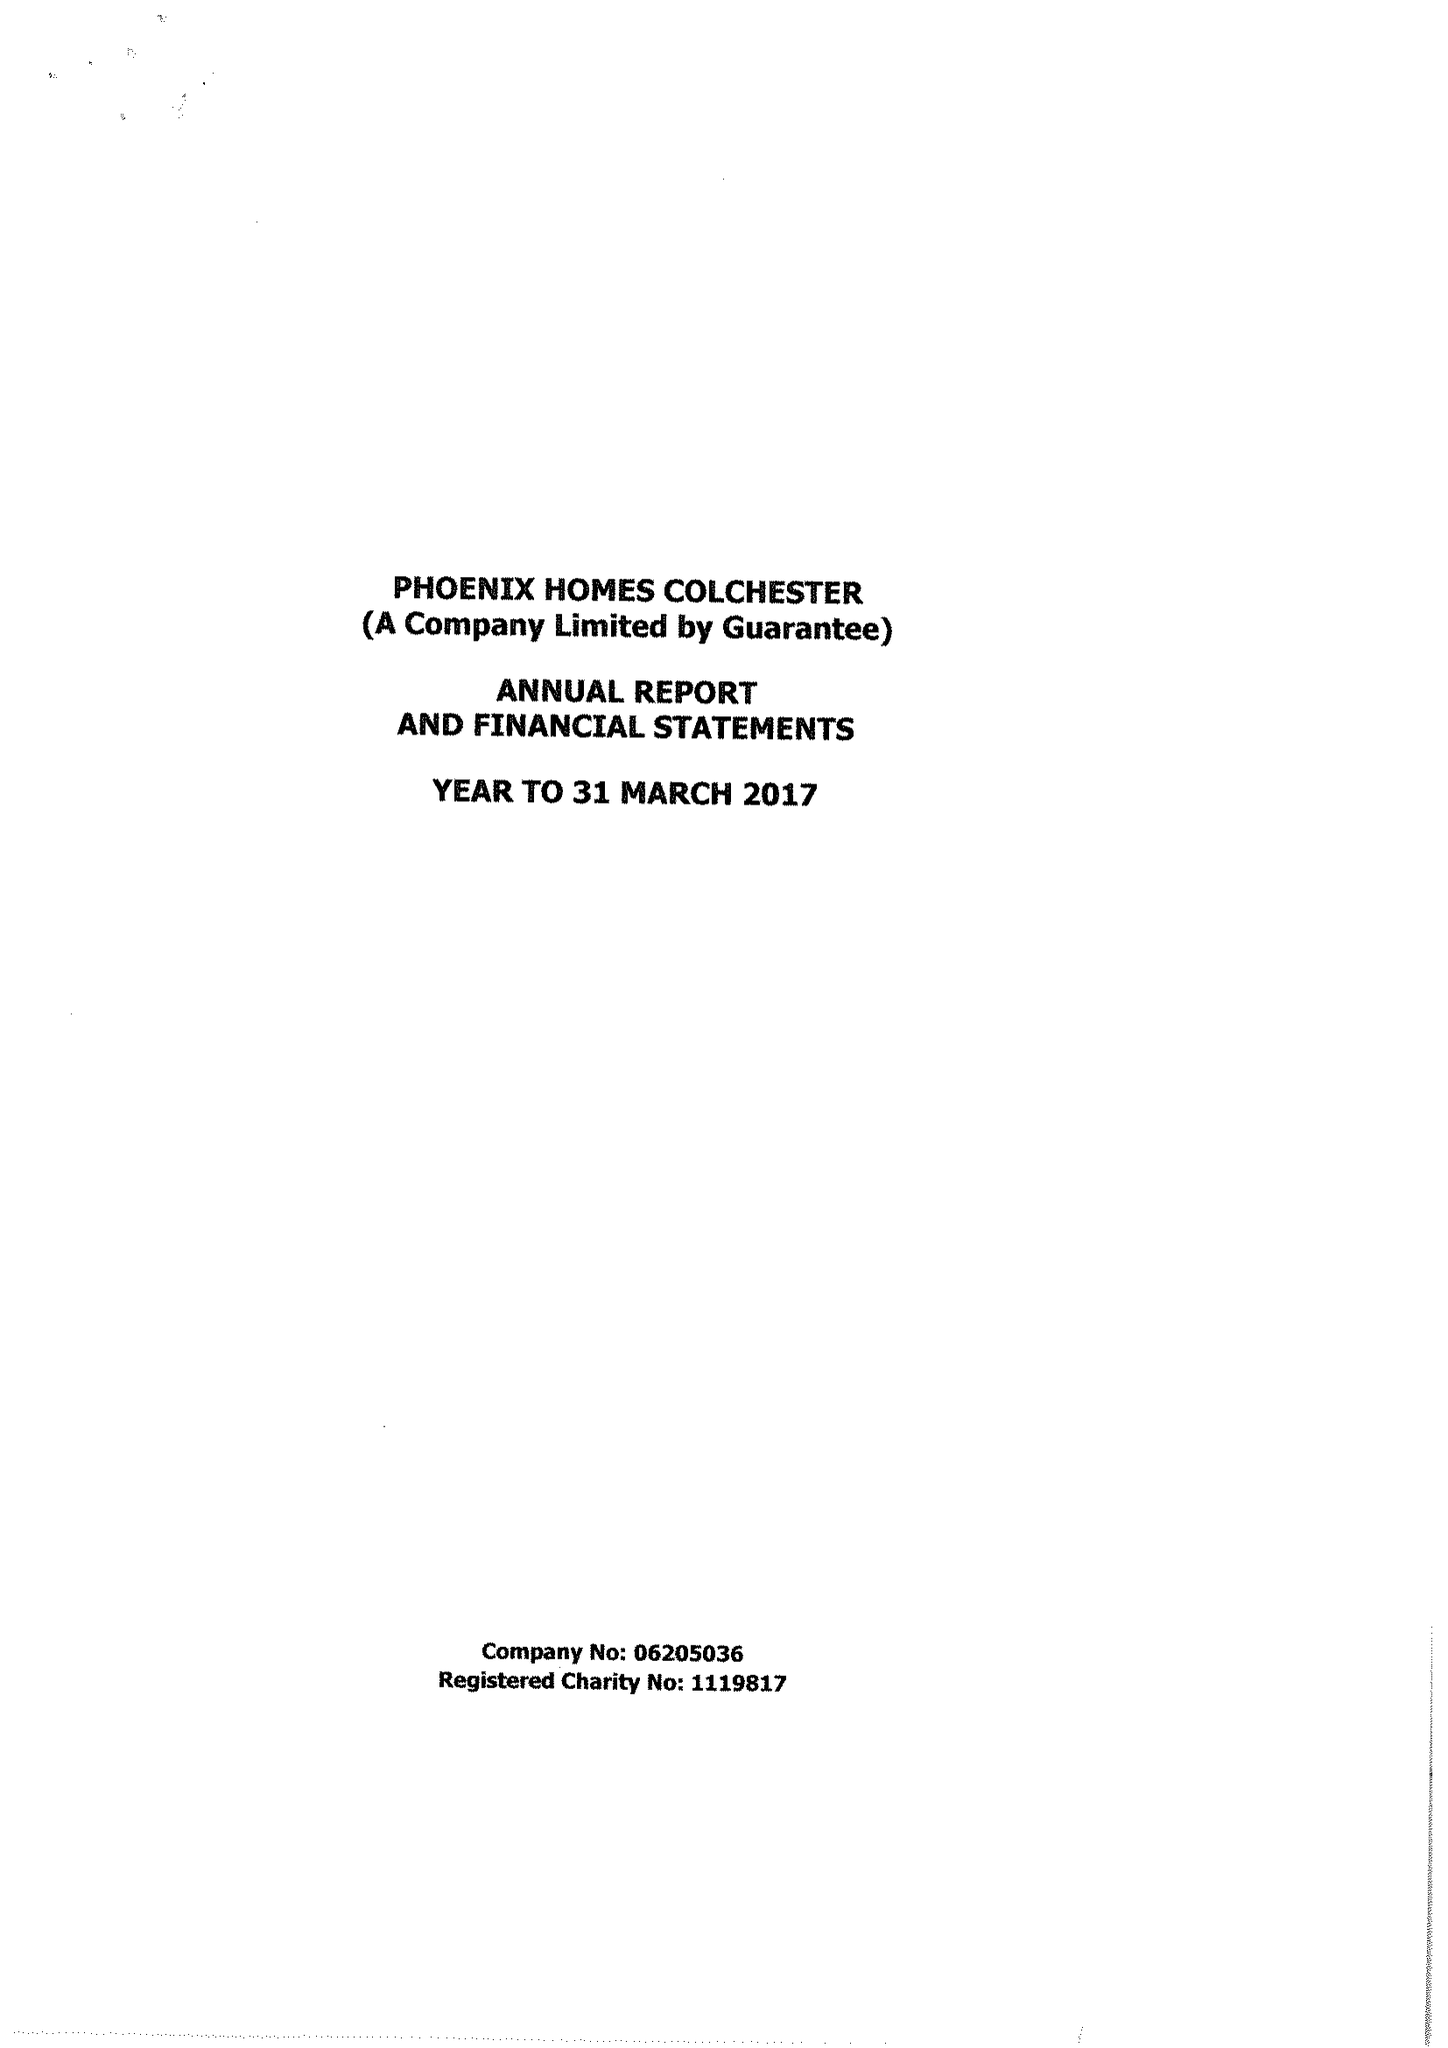What is the value for the address__postcode?
Answer the question using a single word or phrase. CO3 9DE 